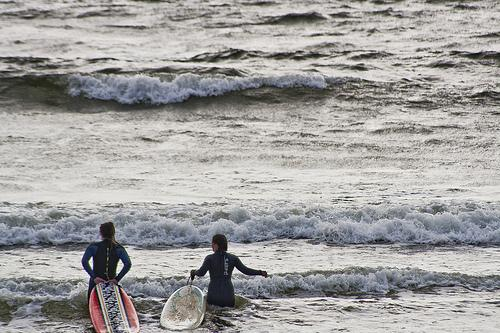Describe the water's appearance and color in the image. The water is wavy, greyish in color, and has foamy waves. Based on the description, is this image showing a calm or rough water situation? The image shows a rough water situation with waves and splashing surf. Mention one striking feature present on each of the two wetsuits worn by the girls. One wetsuit has a yellow detail, while the other wetsuit has a logo on the back. What are the two main activities the girls seem to be involved in? The girls are carrying surfboards and deciding how they will surf. Are there any objects being held by the girls in the image? If yes, what are they holding? Yes, one girl is dragging a surfboard by a rope, and the other is holding a surfboard behind her. How many girls in wetsuits are seen in the picture? Two girls are wearing wetsuits in the picture. Identify the two primary colors of the surfboards in the image. Red and blue-white. What is the general mood or sentiment of the image? The sentiment is adventurous and sporty, with two girls preparing to surf in the ocean. Is there a sunset in the image, and if so, over what kind of landscape? Yes, the sun is setting over the ocean. Count the total number of surfboards visible in the image. There are two surfboards in the image. What time of day is depicted in the image? The image shows the time of day when the sun is setting. Which one is the correct description of a surfboard: red, white, or both? There are two surfboards: one is red and the other is blue and white. How are the two girls with surfboards interacting with each other? They are standing near each other, preparing to surf together. Describe the landscape in the image. The landscape features waves rolling into the shore and the sun setting over the ocean. Is there any text visible in the image? No, there is no visible text in the image. Mention the type of clothing the girls are wearing. Both girls are wearing wetsuits. What color is the arm of the surfer girl? The color of the arm is not distinguishable as it's covered in a wetsuit. What are the two women in the image doing? They are preparing to surf, carrying their surfboards into the water. Identify the type of sport featured in the image. Surfing Are there any animals visible in the image? No, there are no animals visible in the image. What does the girl with a red surfboard have in common with the girl with a blue and white surfboard? Both are females wearing wetsuits and have their hair pulled back. What are the colors mentioned in the image captions? Red, white, blue, grey, and yellow. Identify any anomalies or unusual elements in the image. No anomalies or unusual elements detected. Describe the emotions the image evokes. Adventure, excitement, friendship, and a sense of freedom. Assess the quality of the image in terms of clarity and resolution. The image is of high quality with clear details and good resolution. List all the objects present in the image along with their positions and sizes. red surfboard (X:85, Y:275, W:53, H:53), blue and white surfboard (X:162, Y:283, W:52, H:52), girl in wetsuit (X:87, Y:217, W:52, H:52), second girl in wetsuit (X:198, Y:230, W:50, H:50), waves on landscape (X:22, Y:181, W:246, H:246), girl with ponytail in ocean (X:82, Y:225, W:61, H:61), 2 girls going to surf (X:87, Y:215, W:167, H:167), sun setting over ocean (X:21, Y:17, W:361, H:361), girl dragging surfboard by rope (X:162, Y:235, W:101, H:101), girl holding surfboard behind her (X:85, Y:218, W:104, H:104), two surfers in the water (X:42, Y:181, W:330, H:330) What are the hair colors of the two girls in the image? The hair colors are not clearly distinguishable. What is the location and size of the red surfboard? X:85, Y:275, Width:53, Height:53 What is the state of the water in the image? The water is wavy and moving fast, with foam on the waves and a greyish color. 